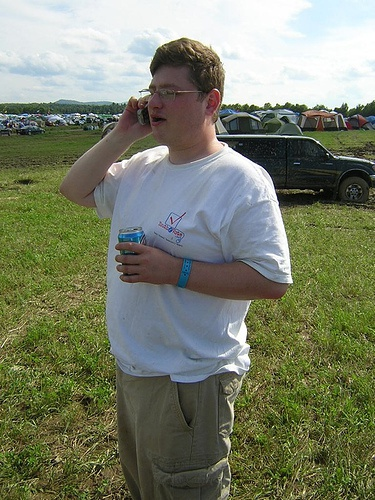Describe the objects in this image and their specific colors. I can see people in white, gray, darkgray, and black tones, truck in white, black, gray, lightgray, and darkgray tones, cell phone in white, black, and gray tones, car in lightgray, black, gray, blue, and darkgray tones, and car in white, black, darkgray, and gray tones in this image. 